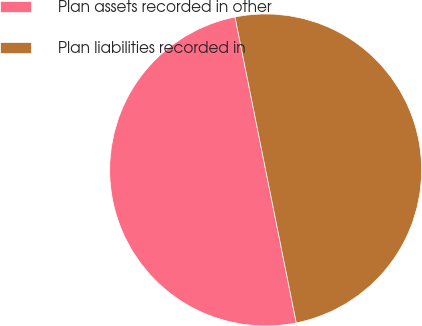Convert chart. <chart><loc_0><loc_0><loc_500><loc_500><pie_chart><fcel>Plan assets recorded in other<fcel>Plan liabilities recorded in<nl><fcel>50.0%<fcel>50.0%<nl></chart> 